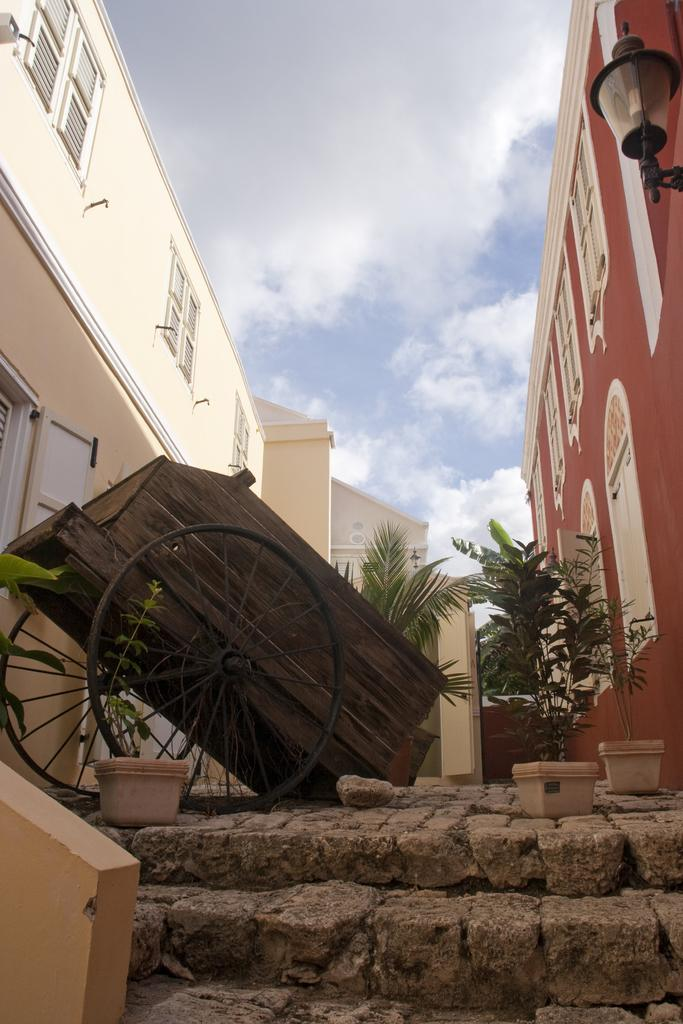What is on the ground in the image? There is a cart on the ground in the image. What type of vegetation is present in the image? There are plants in pots in the image. What can be seen on the buildings in the image? The buildings have windows in the image. What type of lighting is present in the image? There is a street lamp in the image. What architectural feature is visible in the image? There is a staircase in the image. What is the condition of the sky in the image? The sky is visible and appears cloudy in the image. How many oranges are being held by the mother in the image? There is no mother or oranges present in the image. What type of transportation is the passenger using in the image? There is no passenger or transportation present in the image. 